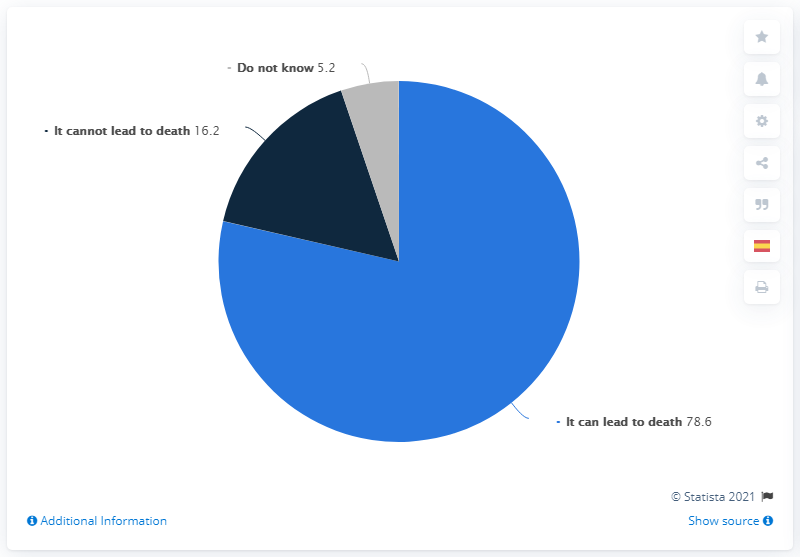Identify some key points in this picture. In my opinion, the greatest reason is the one that can lead to death. The percentage of 'Do Not Know' and 'It Cannot Lead To Death Make Up' is 21.4%. 